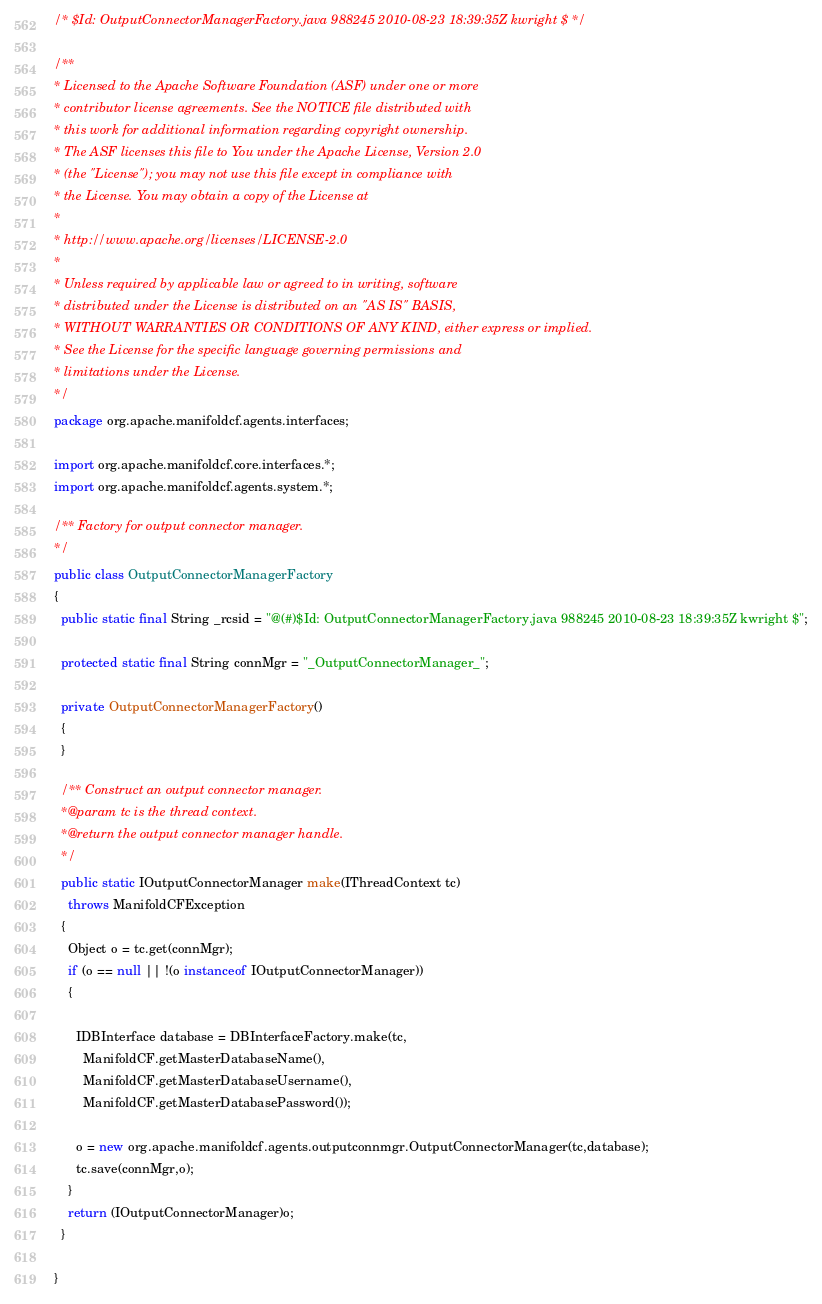<code> <loc_0><loc_0><loc_500><loc_500><_Java_>/* $Id: OutputConnectorManagerFactory.java 988245 2010-08-23 18:39:35Z kwright $ */

/**
* Licensed to the Apache Software Foundation (ASF) under one or more
* contributor license agreements. See the NOTICE file distributed with
* this work for additional information regarding copyright ownership.
* The ASF licenses this file to You under the Apache License, Version 2.0
* (the "License"); you may not use this file except in compliance with
* the License. You may obtain a copy of the License at
*
* http://www.apache.org/licenses/LICENSE-2.0
*
* Unless required by applicable law or agreed to in writing, software
* distributed under the License is distributed on an "AS IS" BASIS,
* WITHOUT WARRANTIES OR CONDITIONS OF ANY KIND, either express or implied.
* See the License for the specific language governing permissions and
* limitations under the License.
*/
package org.apache.manifoldcf.agents.interfaces;

import org.apache.manifoldcf.core.interfaces.*;
import org.apache.manifoldcf.agents.system.*;

/** Factory for output connector manager.
*/
public class OutputConnectorManagerFactory
{
  public static final String _rcsid = "@(#)$Id: OutputConnectorManagerFactory.java 988245 2010-08-23 18:39:35Z kwright $";

  protected static final String connMgr = "_OutputConnectorManager_";

  private OutputConnectorManagerFactory()
  {
  }

  /** Construct an output connector manager.
  *@param tc is the thread context.
  *@return the output connector manager handle.
  */
  public static IOutputConnectorManager make(IThreadContext tc)
    throws ManifoldCFException
  {
    Object o = tc.get(connMgr);
    if (o == null || !(o instanceof IOutputConnectorManager))
    {

      IDBInterface database = DBInterfaceFactory.make(tc,
        ManifoldCF.getMasterDatabaseName(),
        ManifoldCF.getMasterDatabaseUsername(),
        ManifoldCF.getMasterDatabasePassword());

      o = new org.apache.manifoldcf.agents.outputconnmgr.OutputConnectorManager(tc,database);
      tc.save(connMgr,o);
    }
    return (IOutputConnectorManager)o;
  }

}
</code> 